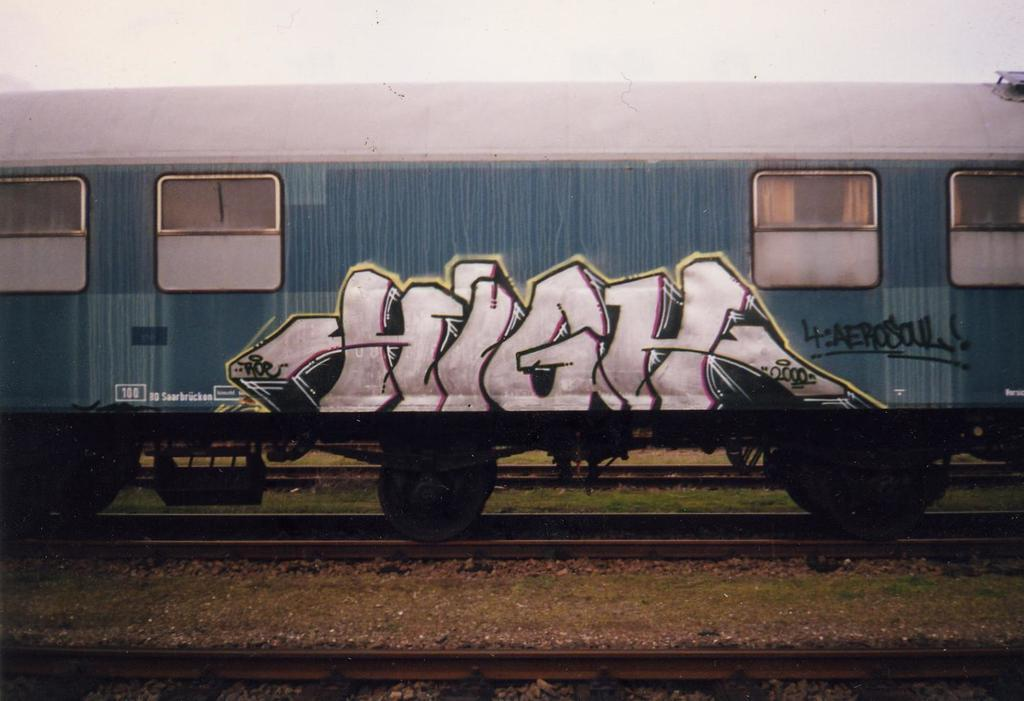<image>
Describe the image concisely. The word high is painted onto the side of a train. 